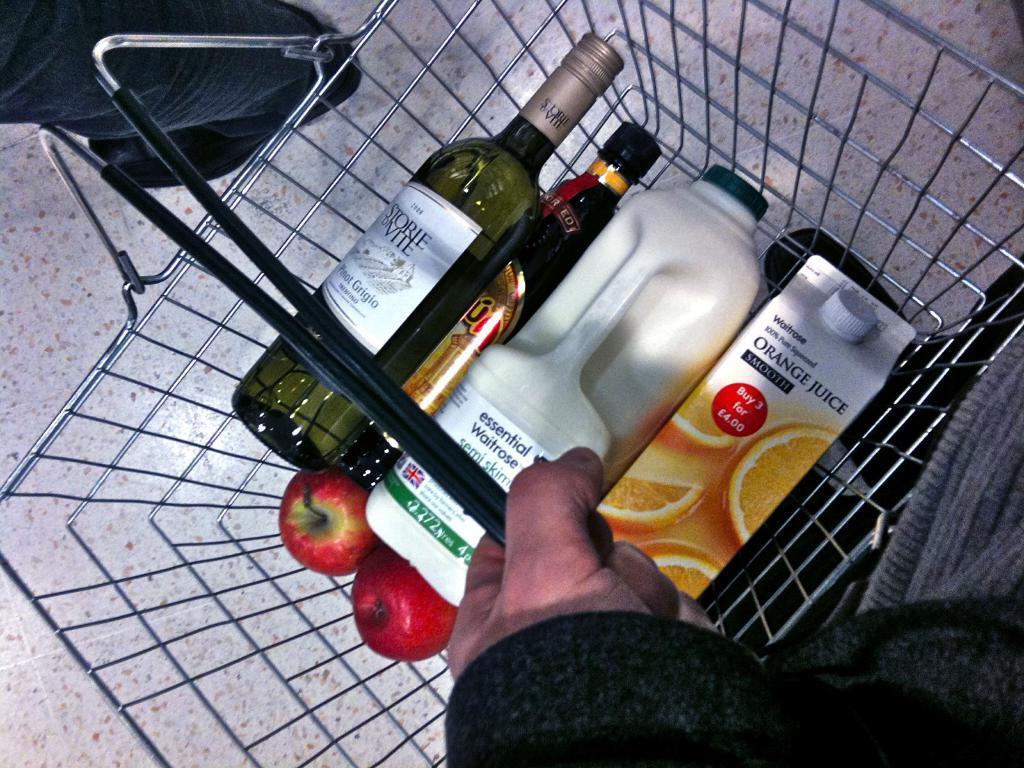Provide a one-sentence caption for the provided image. A grocery basket that has milke and a carton that says Orange Juice on it. 